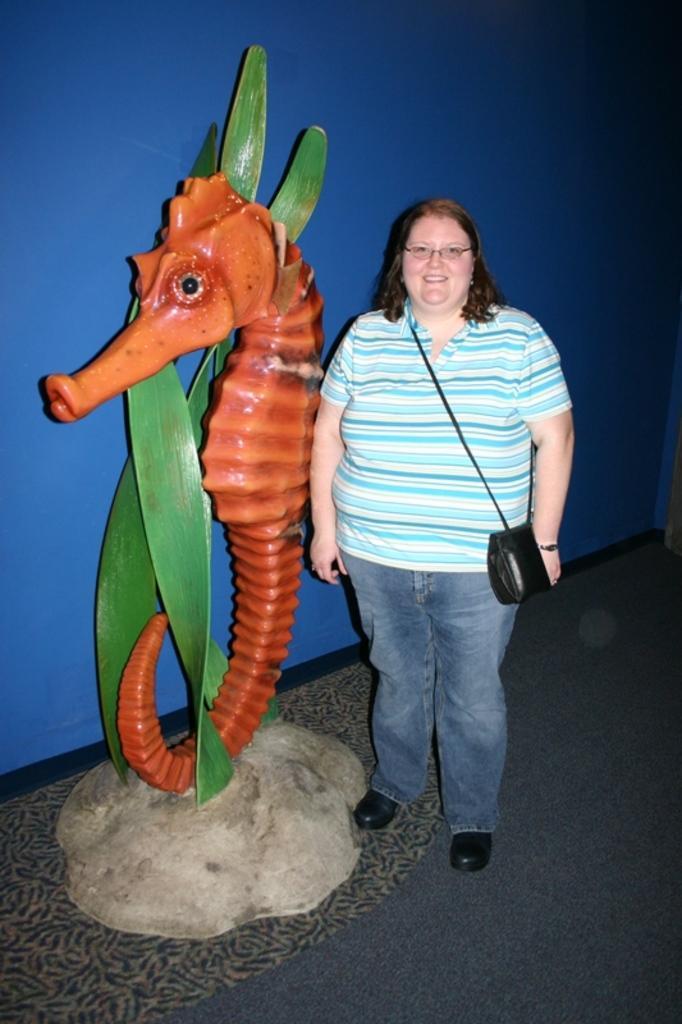In one or two sentences, can you explain what this image depicts? In this image a lady wearing blue and white striped shirt is standing beside a statue of a dragon. She is smiling she is carrying a bag. In the background there is blue wall. These are green leaves life structure. 